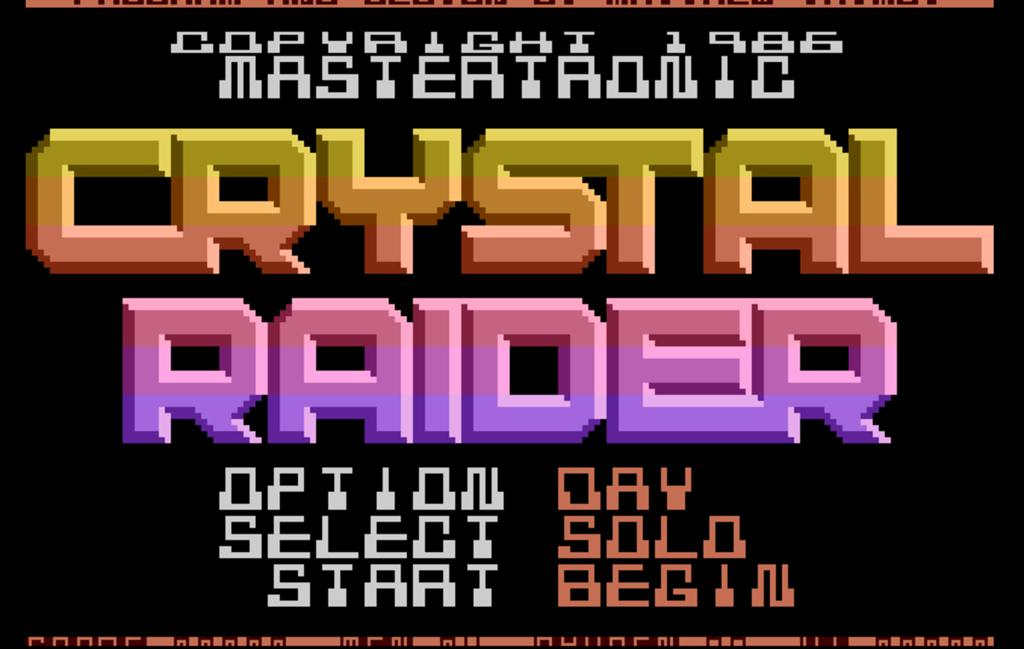<image>
Provide a brief description of the given image. Crystal raider is written in large color on a black poster. 